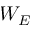Convert formula to latex. <formula><loc_0><loc_0><loc_500><loc_500>W _ { E }</formula> 